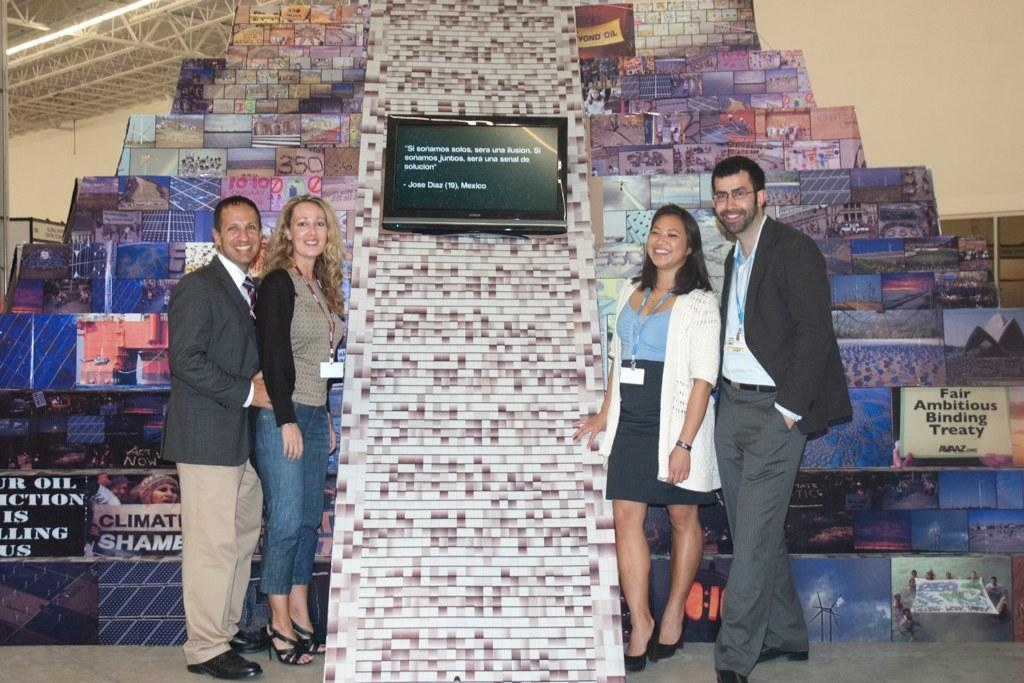What are the people in the image doing? The people in the image are standing and smiling. What electronic device can be seen in the image? There is a television in the image. What objects are present in the image that might be used for displaying information or instructions? There are boards in the image. What objects can be seen in the background of the image? There are rods, a wall, and lights in the background of the image. What type of kettle is being used to boil water in the image? There is no kettle present in the image. What apparatus is being used to measure the distance between the rods in the background? There is no apparatus visible in the image for measuring the distance between the rods. 